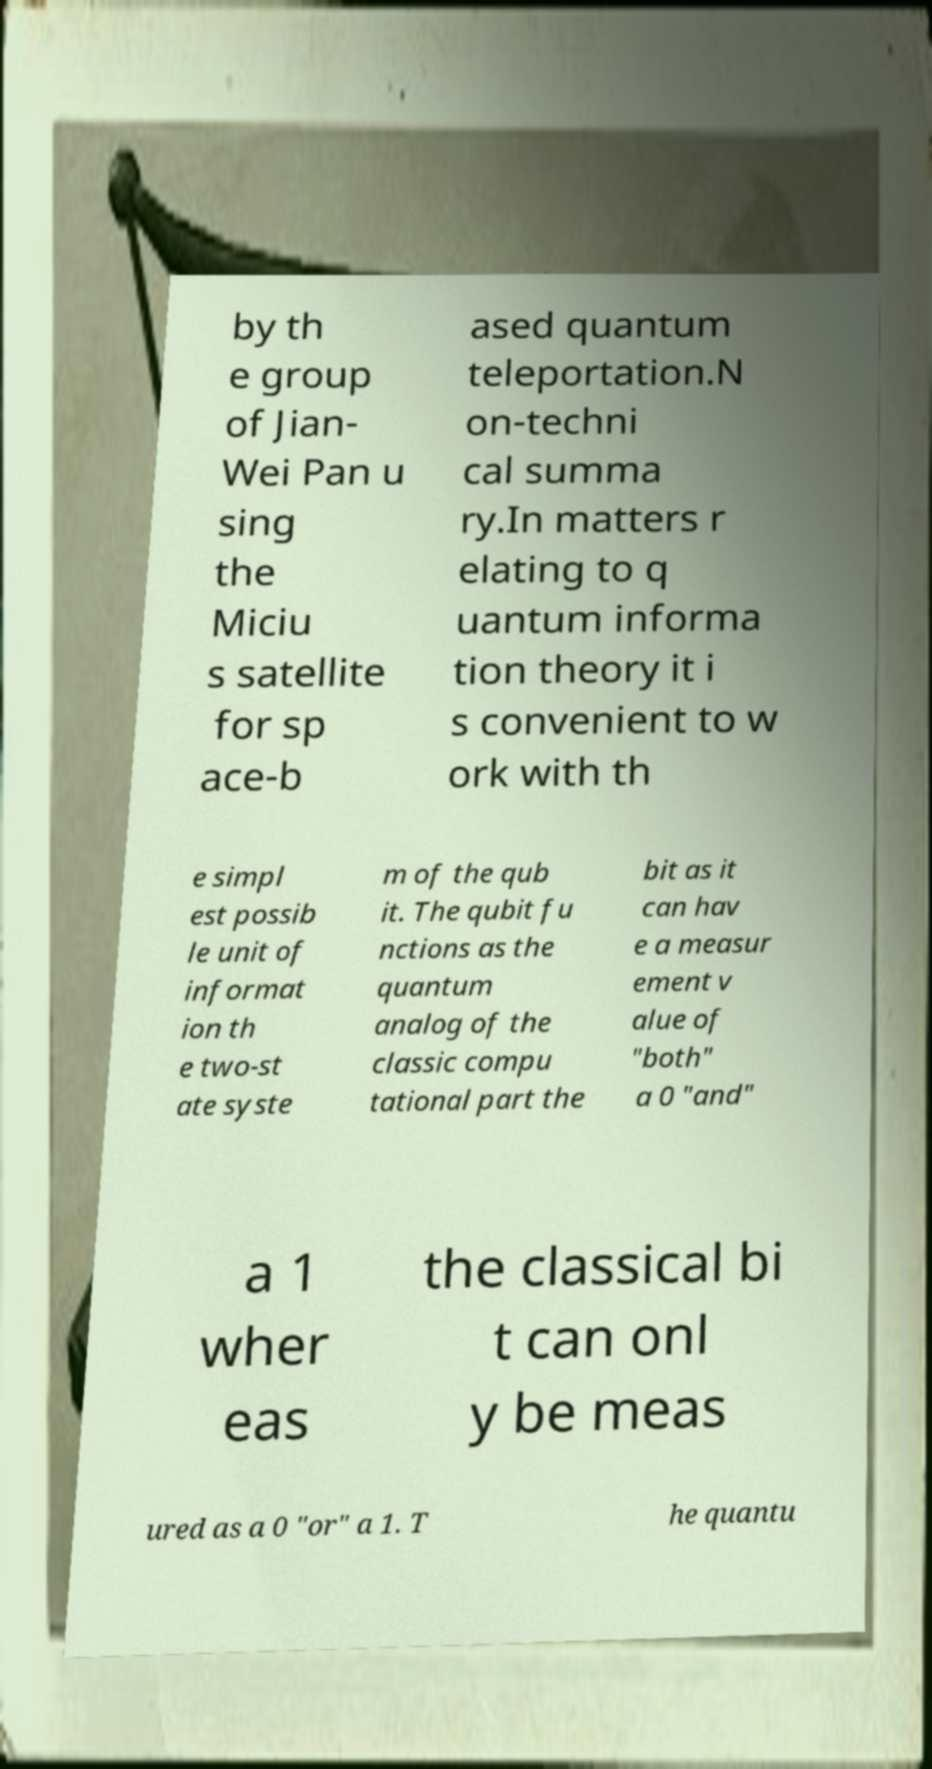Could you extract and type out the text from this image? by th e group of Jian- Wei Pan u sing the Miciu s satellite for sp ace-b ased quantum teleportation.N on-techni cal summa ry.In matters r elating to q uantum informa tion theory it i s convenient to w ork with th e simpl est possib le unit of informat ion th e two-st ate syste m of the qub it. The qubit fu nctions as the quantum analog of the classic compu tational part the bit as it can hav e a measur ement v alue of "both" a 0 "and" a 1 wher eas the classical bi t can onl y be meas ured as a 0 "or" a 1. T he quantu 